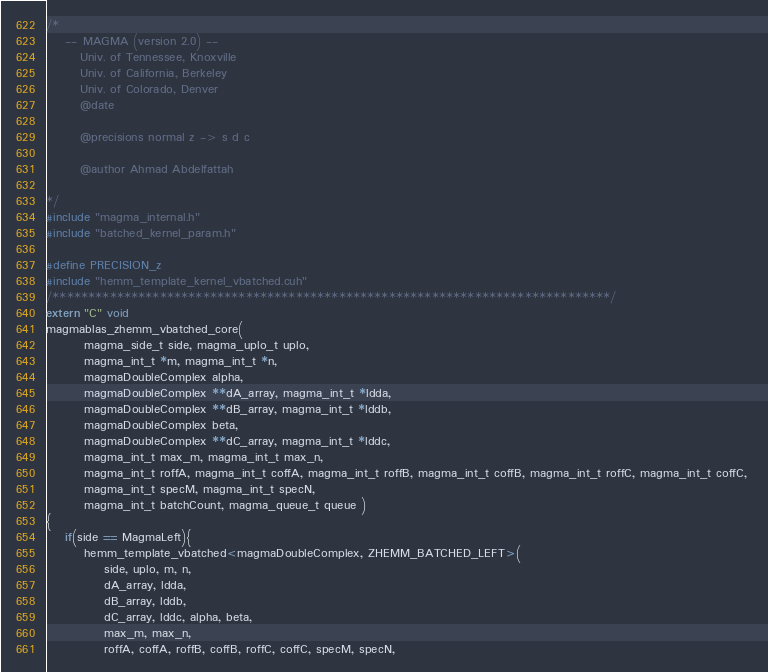Convert code to text. <code><loc_0><loc_0><loc_500><loc_500><_Cuda_>/*
    -- MAGMA (version 2.0) --
       Univ. of Tennessee, Knoxville
       Univ. of California, Berkeley
       Univ. of Colorado, Denver
       @date

       @precisions normal z -> s d c

       @author Ahmad Abdelfattah
       
*/
#include "magma_internal.h"
#include "batched_kernel_param.h"

#define PRECISION_z
#include "hemm_template_kernel_vbatched.cuh"
/******************************************************************************/
extern "C" void 
magmablas_zhemm_vbatched_core(
        magma_side_t side, magma_uplo_t uplo, 
        magma_int_t *m, magma_int_t *n, 
        magmaDoubleComplex alpha, 
        magmaDoubleComplex **dA_array, magma_int_t *ldda,
        magmaDoubleComplex **dB_array, magma_int_t *lddb, 
        magmaDoubleComplex beta, 
        magmaDoubleComplex **dC_array, magma_int_t *lddc, 
        magma_int_t max_m, magma_int_t max_n, 
        magma_int_t roffA, magma_int_t coffA, magma_int_t roffB, magma_int_t coffB, magma_int_t roffC, magma_int_t coffC, 
        magma_int_t specM, magma_int_t specN, 
        magma_int_t batchCount, magma_queue_t queue )
{        
    if(side == MagmaLeft){
        hemm_template_vbatched<magmaDoubleComplex, ZHEMM_BATCHED_LEFT>(
            side, uplo, m, n, 
            dA_array, ldda,
            dB_array, lddb, 
            dC_array, lddc, alpha, beta, 
            max_m, max_n, 
            roffA, coffA, roffB, coffB, roffC, coffC, specM, specN, </code> 